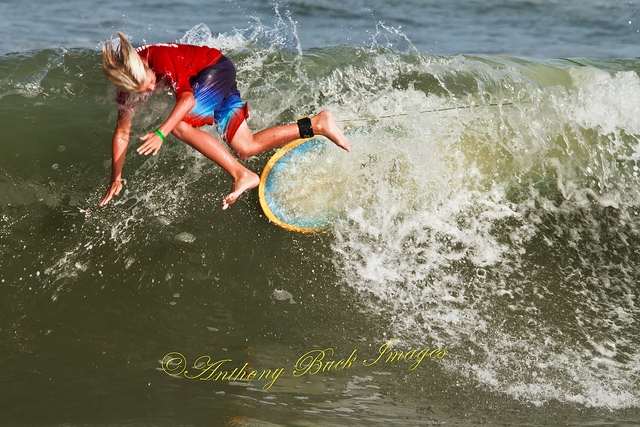Identify the text contained in this image. ANTHONY Buck Images 